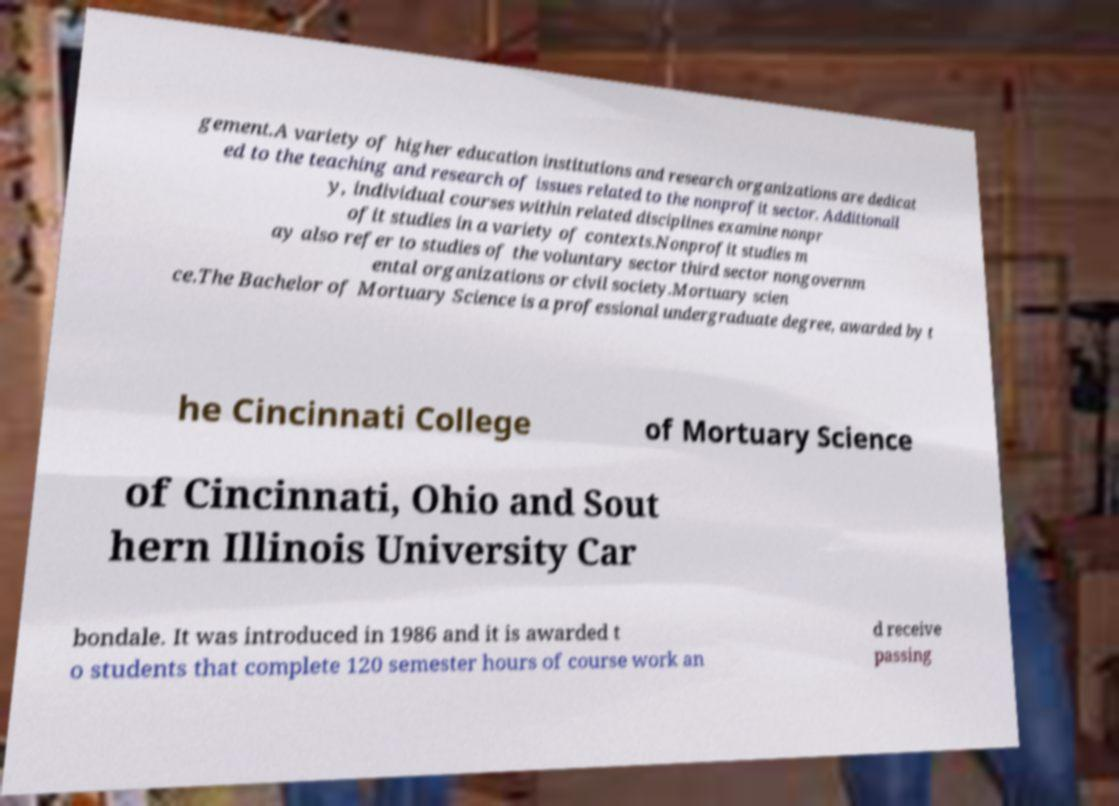Can you read and provide the text displayed in the image?This photo seems to have some interesting text. Can you extract and type it out for me? gement.A variety of higher education institutions and research organizations are dedicat ed to the teaching and research of issues related to the nonprofit sector. Additionall y, individual courses within related disciplines examine nonpr ofit studies in a variety of contexts.Nonprofit studies m ay also refer to studies of the voluntary sector third sector nongovernm ental organizations or civil society.Mortuary scien ce.The Bachelor of Mortuary Science is a professional undergraduate degree, awarded by t he Cincinnati College of Mortuary Science of Cincinnati, Ohio and Sout hern Illinois University Car bondale. It was introduced in 1986 and it is awarded t o students that complete 120 semester hours of course work an d receive passing 